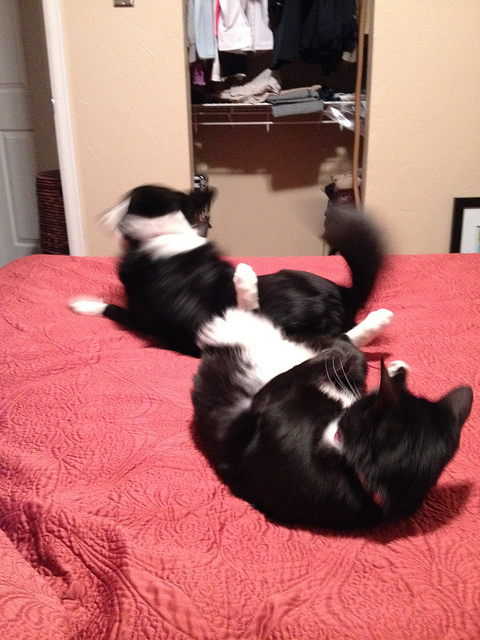How many elephants are facing the camera? There are no elephants to be seen in the image. It appears to be a misunderstanding, as the image actually shows two cats engaging with each other on a red bedspread. None of them resembles an elephant, and hence the question is based on incorrect information. 